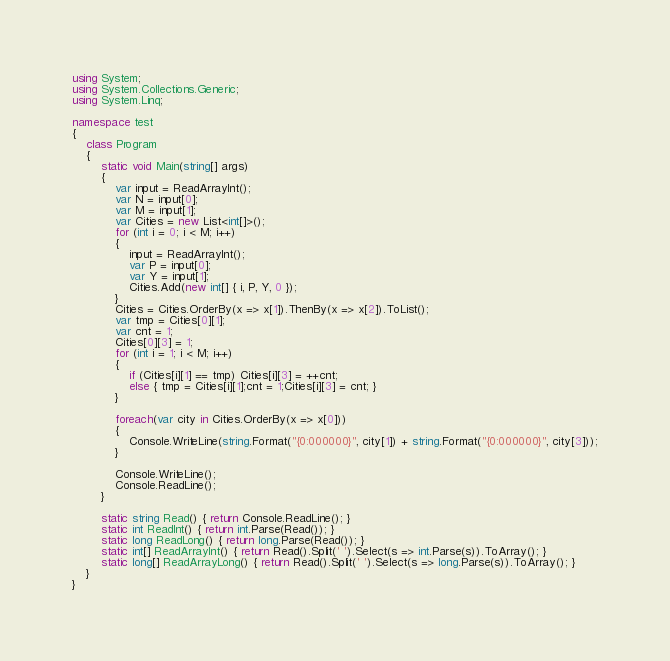<code> <loc_0><loc_0><loc_500><loc_500><_C#_>using System;
using System.Collections.Generic;
using System.Linq;

namespace test
{
    class Program
    {
        static void Main(string[] args)
        {
            var input = ReadArrayInt();
            var N = input[0];
            var M = input[1];
            var Cities = new List<int[]>();            
            for (int i = 0; i < M; i++)
            {
                input = ReadArrayInt();
                var P = input[0];
                var Y = input[1];
                Cities.Add(new int[] { i, P, Y, 0 });
            }
            Cities = Cities.OrderBy(x => x[1]).ThenBy(x => x[2]).ToList();
            var tmp = Cities[0][1];
            var cnt = 1;
            Cities[0][3] = 1;
            for (int i = 1; i < M; i++)
            {
                if (Cities[i][1] == tmp) Cities[i][3] = ++cnt;
                else { tmp = Cities[i][1];cnt = 1;Cities[i][3] = cnt; }
            }

            foreach(var city in Cities.OrderBy(x => x[0]))
            {
                Console.WriteLine(string.Format("{0:000000}", city[1]) + string.Format("{0:000000}", city[3]));
            }            

            Console.WriteLine();
            Console.ReadLine();
        }

        static string Read() { return Console.ReadLine(); }
        static int ReadInt() { return int.Parse(Read()); }
        static long ReadLong() { return long.Parse(Read()); }
        static int[] ReadArrayInt() { return Read().Split(' ').Select(s => int.Parse(s)).ToArray(); }
        static long[] ReadArrayLong() { return Read().Split(' ').Select(s => long.Parse(s)).ToArray(); }
    }
}</code> 